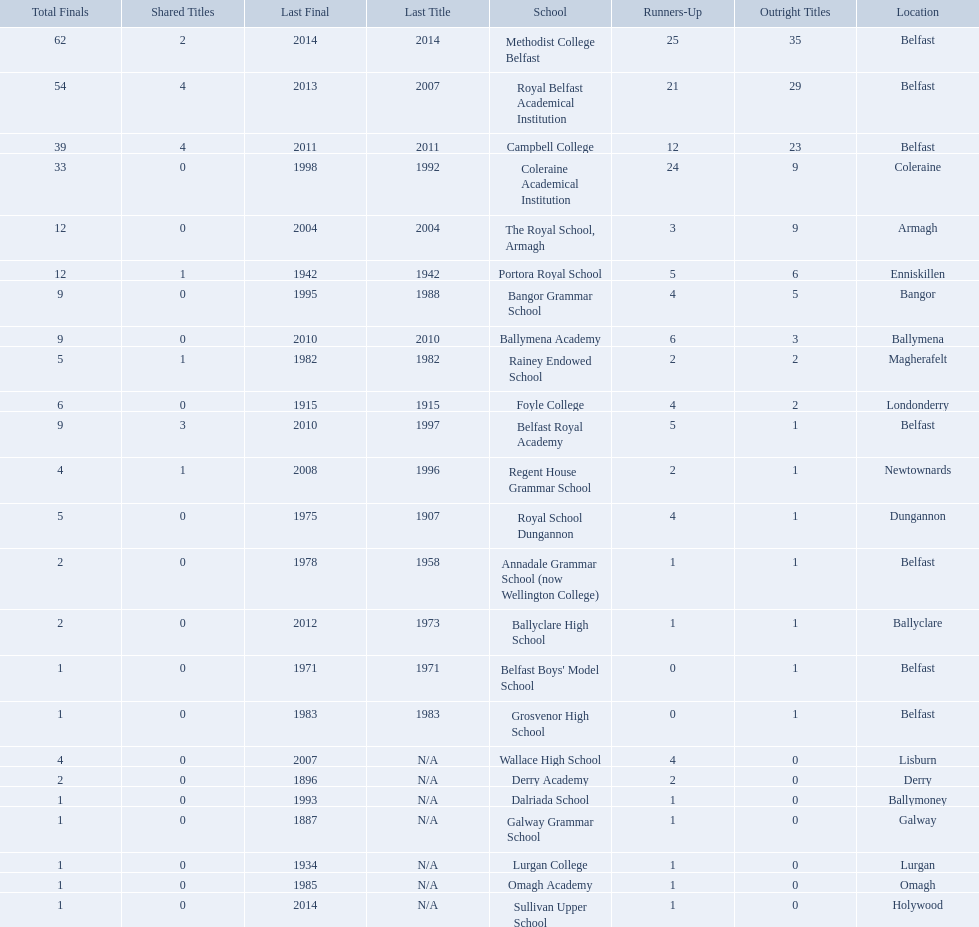How many schools are there? Methodist College Belfast, Royal Belfast Academical Institution, Campbell College, Coleraine Academical Institution, The Royal School, Armagh, Portora Royal School, Bangor Grammar School, Ballymena Academy, Rainey Endowed School, Foyle College, Belfast Royal Academy, Regent House Grammar School, Royal School Dungannon, Annadale Grammar School (now Wellington College), Ballyclare High School, Belfast Boys' Model School, Grosvenor High School, Wallace High School, Derry Academy, Dalriada School, Galway Grammar School, Lurgan College, Omagh Academy, Sullivan Upper School. How many outright titles does the coleraine academical institution have? 9. What other school has the same number of outright titles? The Royal School, Armagh. Which schools are listed? Methodist College Belfast, Royal Belfast Academical Institution, Campbell College, Coleraine Academical Institution, The Royal School, Armagh, Portora Royal School, Bangor Grammar School, Ballymena Academy, Rainey Endowed School, Foyle College, Belfast Royal Academy, Regent House Grammar School, Royal School Dungannon, Annadale Grammar School (now Wellington College), Ballyclare High School, Belfast Boys' Model School, Grosvenor High School, Wallace High School, Derry Academy, Dalriada School, Galway Grammar School, Lurgan College, Omagh Academy, Sullivan Upper School. When did campbell college win the title last? 2011. When did regent house grammar school win the title last? 1996. Of those two who had the most recent title win? Campbell College. 